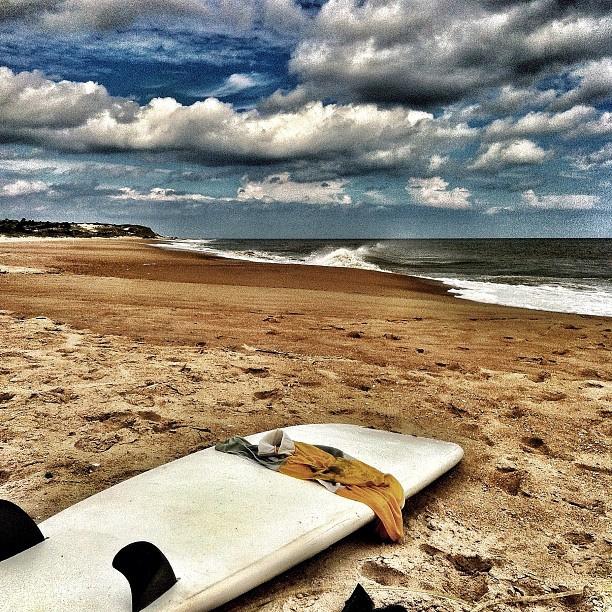What color is the surfboard?
Keep it brief. White. What body of water is in the picture?
Write a very short answer. Ocean. Is it low tide or high tide?
Short answer required. Low. 